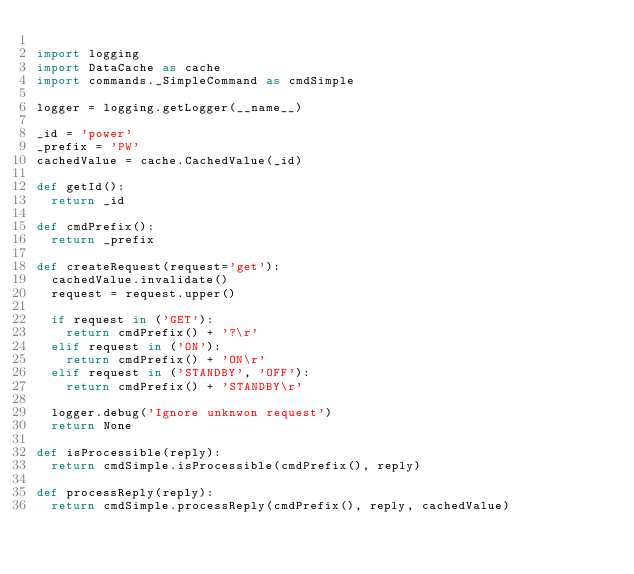<code> <loc_0><loc_0><loc_500><loc_500><_Python_>
import logging
import DataCache as cache
import commands._SimpleCommand as cmdSimple

logger = logging.getLogger(__name__)

_id = 'power'
_prefix = 'PW'
cachedValue = cache.CachedValue(_id)

def getId():
  return _id

def cmdPrefix():
  return _prefix

def createRequest(request='get'):
  cachedValue.invalidate()
  request = request.upper()

  if request in ('GET'):
    return cmdPrefix() + '?\r'
  elif request in ('ON'):
    return cmdPrefix() + 'ON\r'
  elif request in ('STANDBY', 'OFF'):
    return cmdPrefix() + 'STANDBY\r'

  logger.debug('Ignore unknwon request')
  return None

def isProcessible(reply):
  return cmdSimple.isProcessible(cmdPrefix(), reply)

def processReply(reply):
  return cmdSimple.processReply(cmdPrefix(), reply, cachedValue)
</code> 